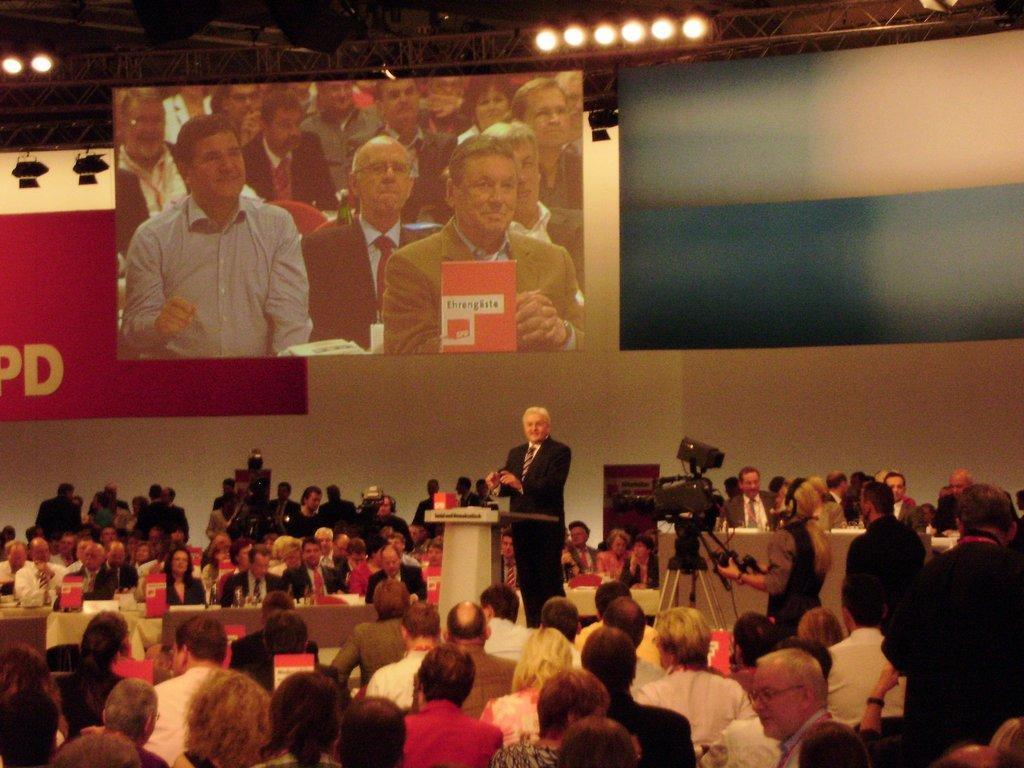Describe this image in one or two sentences. In the image in the center, we can see a group of people are sitting around the table. On the table, we can see the banners and a few other objects. And we can see one person standing. In front of him, there is a stand, camera and microphone. In the background there is a banner, screen and lights. 